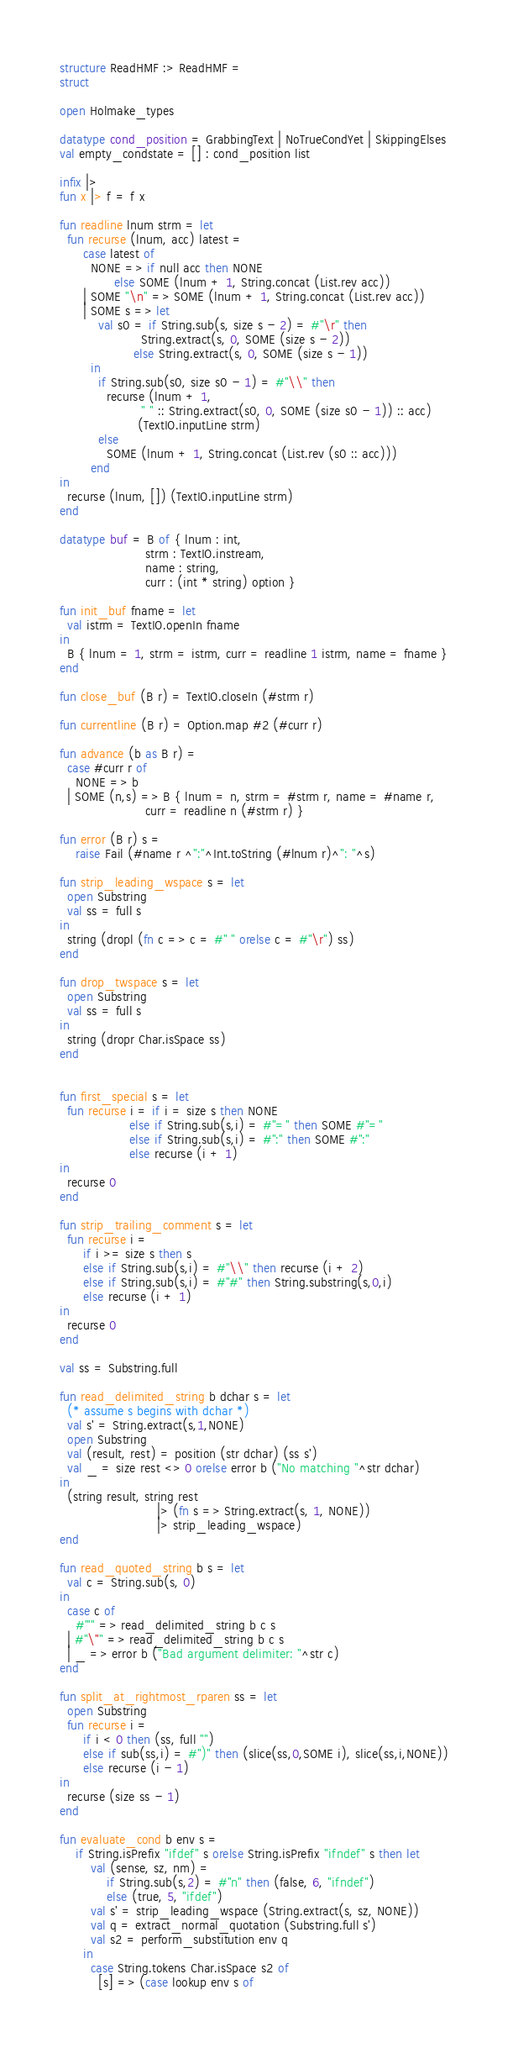Convert code to text. <code><loc_0><loc_0><loc_500><loc_500><_SML_>structure ReadHMF :> ReadHMF =
struct

open Holmake_types

datatype cond_position = GrabbingText | NoTrueCondYet | SkippingElses
val empty_condstate = [] : cond_position list

infix |>
fun x |> f = f x

fun readline lnum strm = let
  fun recurse (lnum, acc) latest =
      case latest of
        NONE => if null acc then NONE
              else SOME (lnum + 1, String.concat (List.rev acc))
      | SOME "\n" => SOME (lnum + 1, String.concat (List.rev acc))
      | SOME s => let
          val s0 = if String.sub(s, size s - 2) = #"\r" then
                     String.extract(s, 0, SOME (size s - 2))
                   else String.extract(s, 0, SOME (size s - 1))
        in
          if String.sub(s0, size s0 - 1) = #"\\" then
            recurse (lnum + 1,
                     " " :: String.extract(s0, 0, SOME (size s0 - 1)) :: acc)
                    (TextIO.inputLine strm)
          else
            SOME (lnum + 1, String.concat (List.rev (s0 :: acc)))
        end
in
  recurse (lnum, []) (TextIO.inputLine strm)
end

datatype buf = B of { lnum : int,
                      strm : TextIO.instream,
                      name : string,
                      curr : (int * string) option }

fun init_buf fname = let
  val istrm = TextIO.openIn fname
in
  B { lnum = 1, strm = istrm, curr = readline 1 istrm, name = fname }
end

fun close_buf (B r) = TextIO.closeIn (#strm r)

fun currentline (B r) = Option.map #2 (#curr r)

fun advance (b as B r) =
  case #curr r of
    NONE => b
  | SOME (n,s) => B { lnum = n, strm = #strm r, name = #name r,
                      curr = readline n (#strm r) }

fun error (B r) s =
    raise Fail (#name r ^":"^Int.toString (#lnum r)^": "^s)

fun strip_leading_wspace s = let
  open Substring
  val ss = full s
in
  string (dropl (fn c => c = #" " orelse c = #"\r") ss)
end

fun drop_twspace s = let
  open Substring
  val ss = full s
in
  string (dropr Char.isSpace ss)
end


fun first_special s = let
  fun recurse i = if i = size s then NONE
                  else if String.sub(s,i) = #"=" then SOME #"="
                  else if String.sub(s,i) = #":" then SOME #":"
                  else recurse (i + 1)
in
  recurse 0
end

fun strip_trailing_comment s = let
  fun recurse i =
      if i >= size s then s
      else if String.sub(s,i) = #"\\" then recurse (i + 2)
      else if String.sub(s,i) = #"#" then String.substring(s,0,i)
      else recurse (i + 1)
in
  recurse 0
end

val ss = Substring.full

fun read_delimited_string b dchar s = let
  (* assume s begins with dchar *)
  val s' = String.extract(s,1,NONE)
  open Substring
  val (result, rest) = position (str dchar) (ss s')
  val _ = size rest <> 0 orelse error b ("No matching "^str dchar)
in
  (string result, string rest
                         |> (fn s => String.extract(s, 1, NONE))
                         |> strip_leading_wspace)
end

fun read_quoted_string b s = let
  val c = String.sub(s, 0)
in
  case c of
    #"'" => read_delimited_string b c s
  | #"\"" => read_delimited_string b c s
  | _ => error b ("Bad argument delimiter: "^str c)
end

fun split_at_rightmost_rparen ss = let
  open Substring
  fun recurse i =
      if i < 0 then (ss, full "")
      else if sub(ss,i) = #")" then (slice(ss,0,SOME i), slice(ss,i,NONE))
      else recurse (i - 1)
in
  recurse (size ss - 1)
end

fun evaluate_cond b env s =
    if String.isPrefix "ifdef" s orelse String.isPrefix "ifndef" s then let
        val (sense, sz, nm) =
            if String.sub(s,2) = #"n" then (false, 6, "ifndef")
            else (true, 5, "ifdef")
        val s' = strip_leading_wspace (String.extract(s, sz, NONE))
        val q = extract_normal_quotation (Substring.full s')
        val s2 = perform_substitution env q
      in
        case String.tokens Char.isSpace s2 of
          [s] => (case lookup env s of</code> 